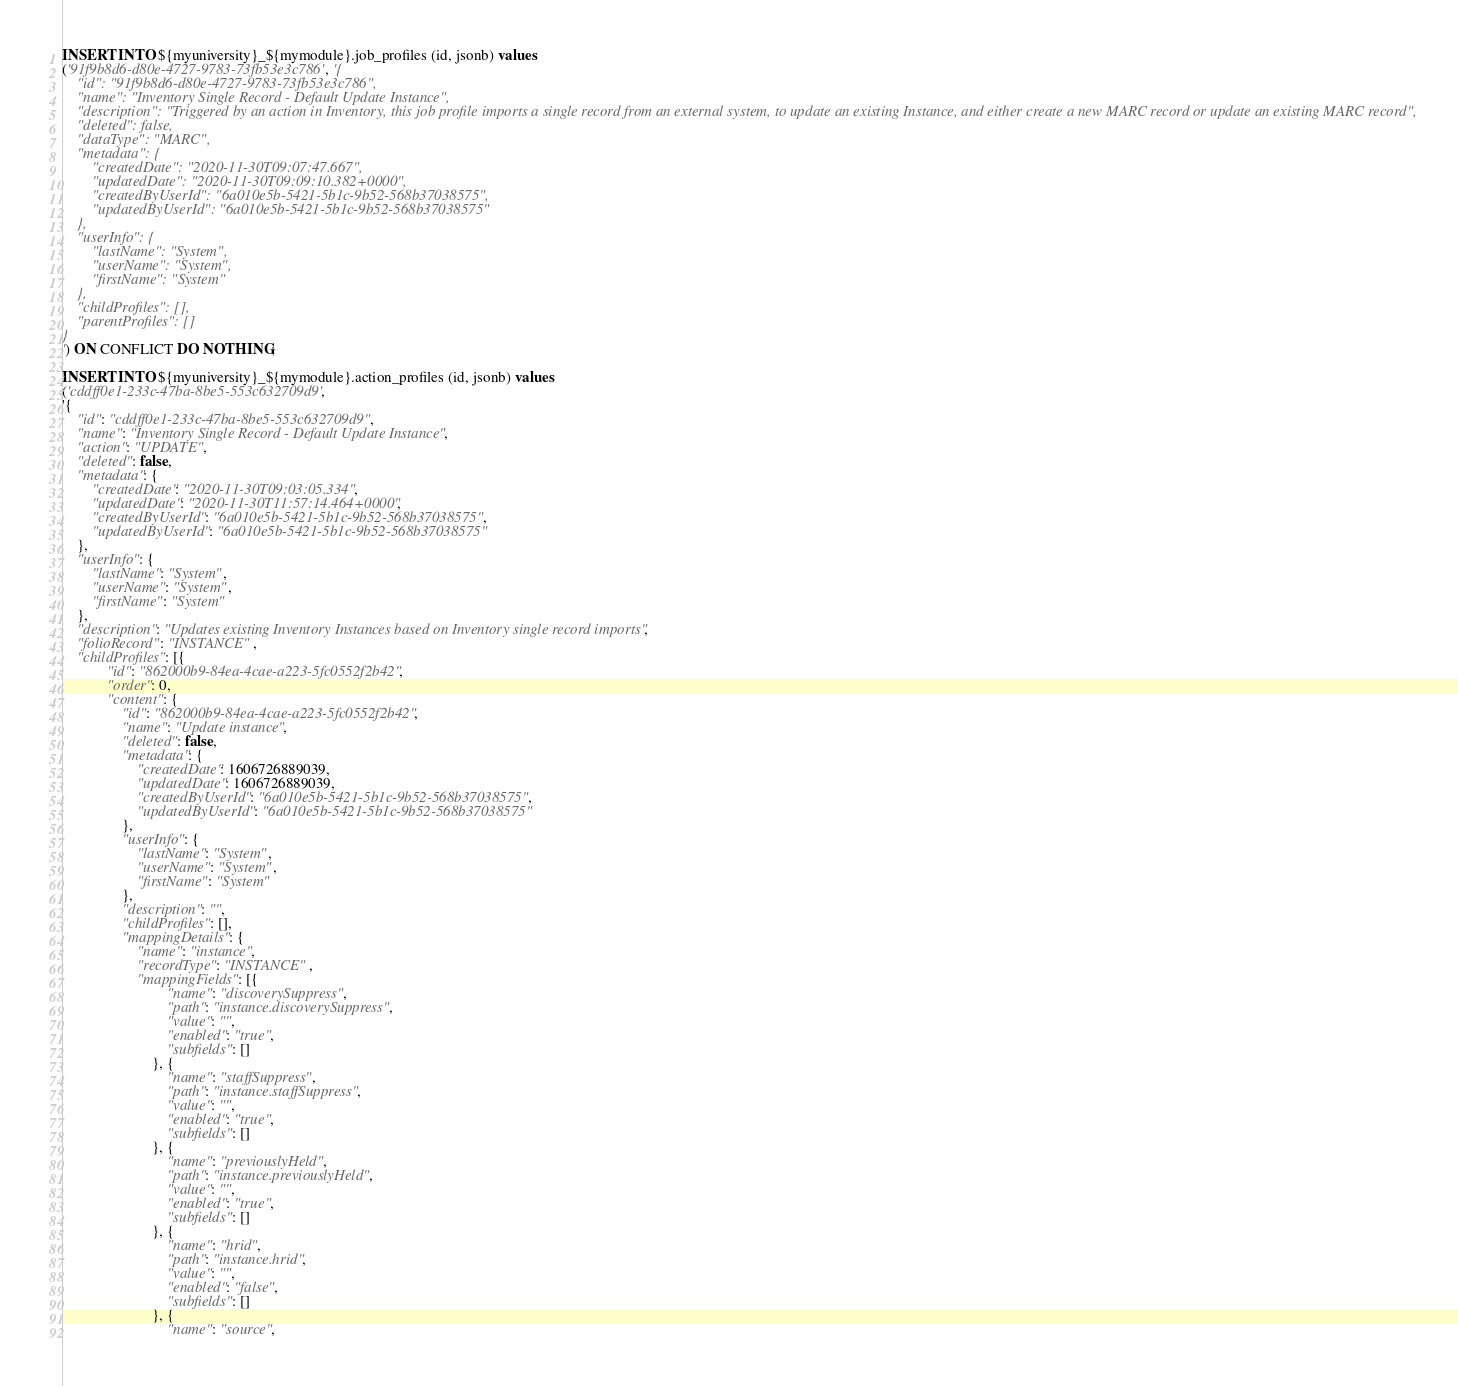<code> <loc_0><loc_0><loc_500><loc_500><_SQL_>INSERT INTO ${myuniversity}_${mymodule}.job_profiles (id, jsonb) values
('91f9b8d6-d80e-4727-9783-73fb53e3c786', '{
	"id": "91f9b8d6-d80e-4727-9783-73fb53e3c786",
	"name": "Inventory Single Record - Default Update Instance",
	"description": "Triggered by an action in Inventory, this job profile imports a single record from an external system, to update an existing Instance, and either create a new MARC record or update an existing MARC record",
	"deleted": false,
	"dataType": "MARC",
	"metadata": {
		"createdDate": "2020-11-30T09:07:47.667",
		"updatedDate": "2020-11-30T09:09:10.382+0000",
		"createdByUserId": "6a010e5b-5421-5b1c-9b52-568b37038575",
		"updatedByUserId": "6a010e5b-5421-5b1c-9b52-568b37038575"
	},
	"userInfo": {
		"lastName": "System",
		"userName": "System",
		"firstName": "System"
	},
	"childProfiles": [],
	"parentProfiles": []
}
') ON CONFLICT DO NOTHING;

INSERT INTO ${myuniversity}_${mymodule}.action_profiles (id, jsonb) values
('cddff0e1-233c-47ba-8be5-553c632709d9',
'{
	"id": "cddff0e1-233c-47ba-8be5-553c632709d9",
	"name": "Inventory Single Record - Default Update Instance",
	"action": "UPDATE",
	"deleted": false,
	"metadata": {
		"createdDate": "2020-11-30T09:03:05.334",
		"updatedDate": "2020-11-30T11:57:14.464+0000",
		"createdByUserId": "6a010e5b-5421-5b1c-9b52-568b37038575",
		"updatedByUserId": "6a010e5b-5421-5b1c-9b52-568b37038575"
	},
	"userInfo": {
		"lastName": "System",
		"userName": "System",
		"firstName": "System"
	},
	"description": "Updates existing Inventory Instances based on Inventory single record imports",
	"folioRecord": "INSTANCE",
	"childProfiles": [{
			"id": "862000b9-84ea-4cae-a223-5fc0552f2b42",
			"order": 0,
			"content": {
				"id": "862000b9-84ea-4cae-a223-5fc0552f2b42",
				"name": "Update instance",
				"deleted": false,
				"metadata": {
					"createdDate": 1606726889039,
					"updatedDate": 1606726889039,
					"createdByUserId": "6a010e5b-5421-5b1c-9b52-568b37038575",
					"updatedByUserId": "6a010e5b-5421-5b1c-9b52-568b37038575"
				},
				"userInfo": {
					"lastName": "System",
					"userName": "System",
					"firstName": "System"
				},
				"description": "",
				"childProfiles": [],
				"mappingDetails": {
					"name": "instance",
					"recordType": "INSTANCE",
					"mappingFields": [{
							"name": "discoverySuppress",
							"path": "instance.discoverySuppress",
							"value": "",
							"enabled": "true",
							"subfields": []
						}, {
							"name": "staffSuppress",
							"path": "instance.staffSuppress",
							"value": "",
							"enabled": "true",
							"subfields": []
						}, {
							"name": "previouslyHeld",
							"path": "instance.previouslyHeld",
							"value": "",
							"enabled": "true",
							"subfields": []
						}, {
							"name": "hrid",
							"path": "instance.hrid",
							"value": "",
							"enabled": "false",
							"subfields": []
						}, {
							"name": "source",</code> 